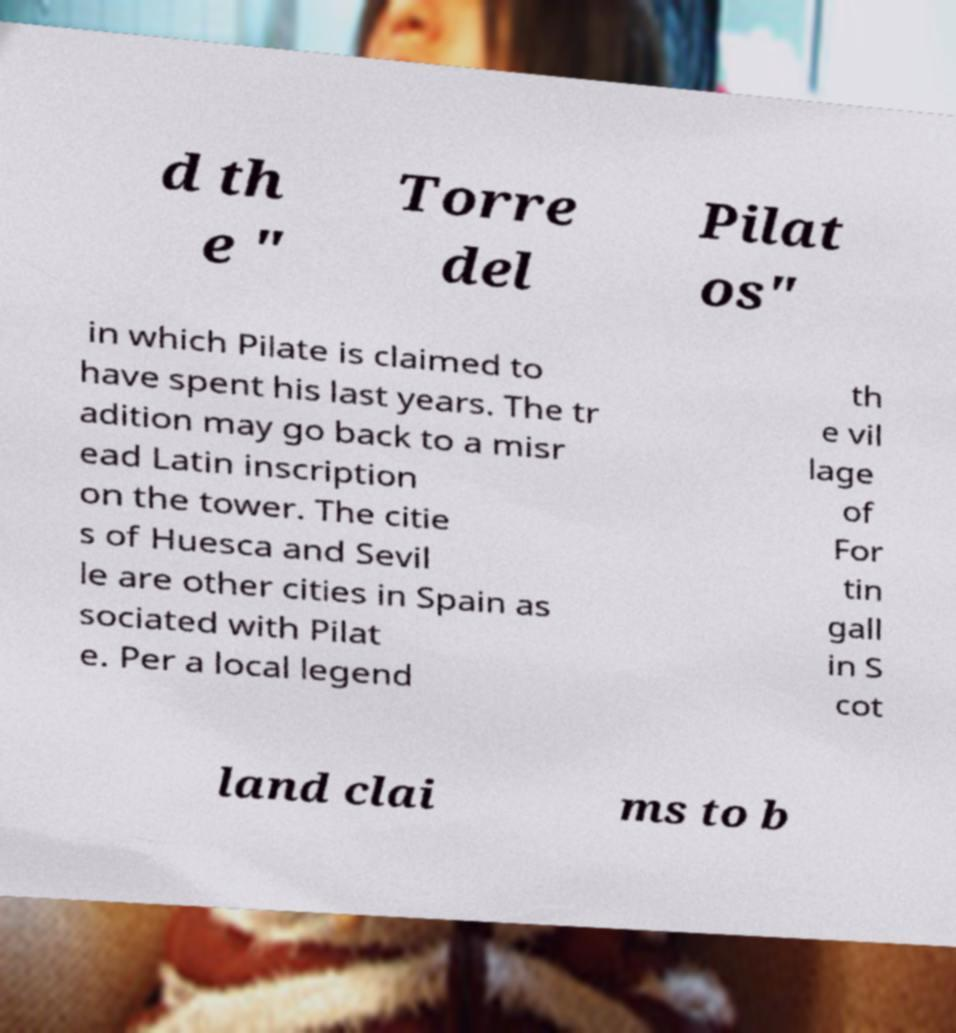Please read and relay the text visible in this image. What does it say? d th e " Torre del Pilat os" in which Pilate is claimed to have spent his last years. The tr adition may go back to a misr ead Latin inscription on the tower. The citie s of Huesca and Sevil le are other cities in Spain as sociated with Pilat e. Per a local legend th e vil lage of For tin gall in S cot land clai ms to b 